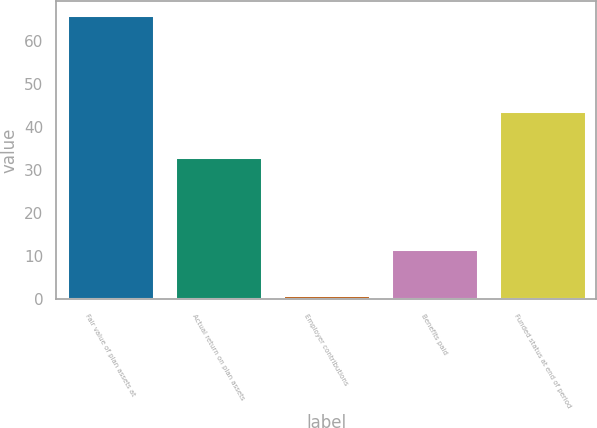Convert chart. <chart><loc_0><loc_0><loc_500><loc_500><bar_chart><fcel>Fair value of plan assets at<fcel>Actual return on plan assets<fcel>Employer contributions<fcel>Benefits paid<fcel>Funded status at end of period<nl><fcel>66<fcel>33<fcel>1<fcel>11.6<fcel>43.6<nl></chart> 